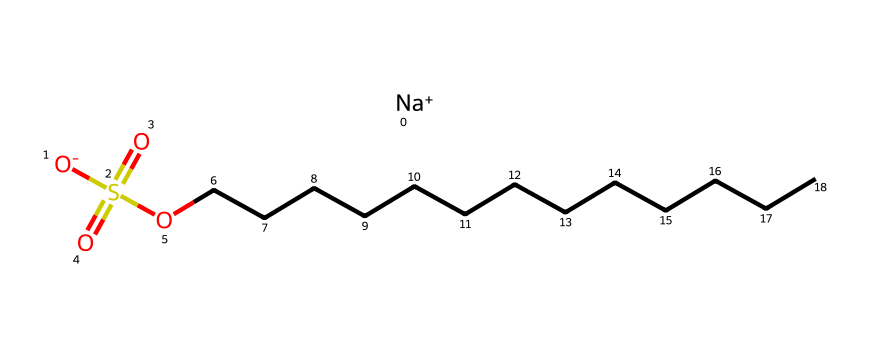What is the central atom in this chemical structure? The chemical structure has a sulfur atom at its center, surrounded by various functional groups. The presence of the sulfur atom is indicated by "S" in the SMILES representation.
Answer: sulfur How many oxygen atoms are present in this molecule? By examining the SMILES, we can see there are four oxygen atoms, represented by "O" appearing in the structure, including one that is part of the sulfate group.
Answer: four Which functional group does the "S(=O)(=O)" represent? The notation "S(=O)(=O)" indicates a sulfonic acid group due to the presence of sulfur bonded to two double-bonded oxygen atoms and one hydroxyl group. This configuration defines the functional group.
Answer: sulfonic acid What type of ionic species is represented by "[Na+]"? The "[Na+]" notation indicates a sodium cation, which is a positively charged ion commonly found in ionic compounds. This highlights that the molecule has a sodium component.
Answer: sodium cation What is the main characteristic of the hydrocarbon chain "CCCCCCCCCCCCC"? The hydrocarbon chain "CCCCCCCCCCCCC" is a long linear alkane chain, which indicates it is non-polar and hydrophobic, contributing to the molecule's behavior in water.
Answer: hydrophobic What does the presence of the sulfate group imply about this soap? The presence of the sulfate group suggests that this soap has amphiphilic properties, making it capable of interacting with both water and oils, which is essential for its function as a cleaning agent.
Answer: amphiphilic How does the sodium ion affect the solubility of this chemical in water? The sodium ion increases the solubility of the molecule in water because the positive charge of sodium interacts favorably with the polar water molecules, facilitating dissolution.
Answer: increases solubility 